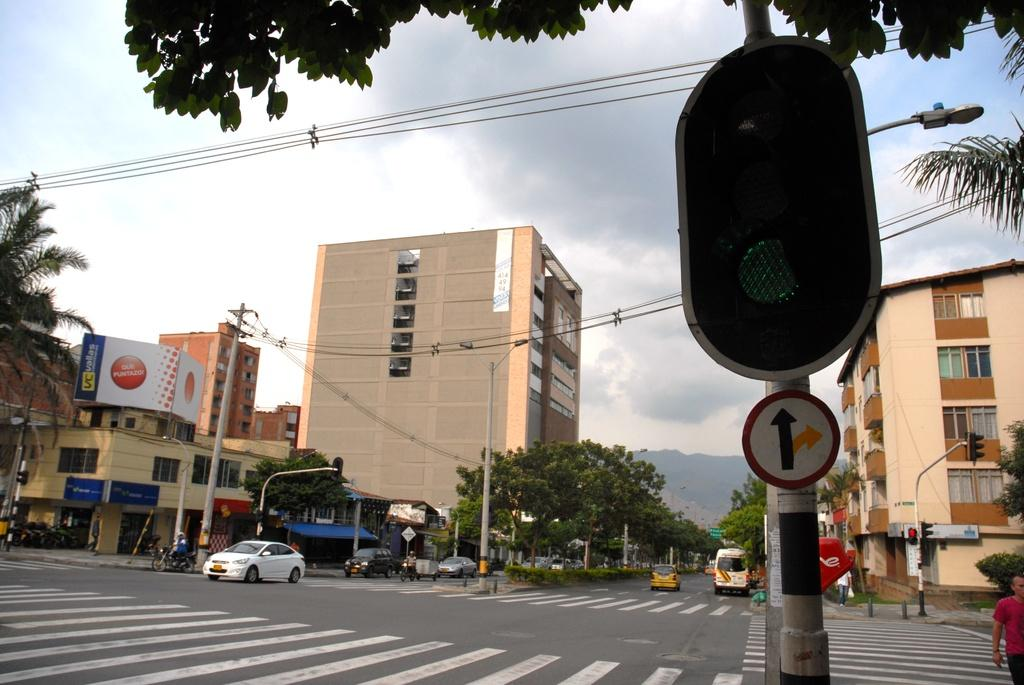What type of structures can be seen in the image? There are buildings in the image. What are the large, flat surfaces with advertisements on them? There are hoardings in the image. What are the tall, thin objects in the image? There are poles in the image. What type of vegetation is present in the image? There are trees in the image. What type of transportation can be seen in the image? There are vehicles in the image. What are the signs with information or directions on them? There are sign boards in the image. What are the lights used for controlling traffic? There are signal lights in the image. Are there any living beings in the image? Yes, there are people in the image. What type of flora is present in the image? There are plants in the image. What is the condition of the sky in the image? The sky is cloudy in the image. What general category of items can be seen in the image? There are objects in the image. Can you see any toes on the people in the image? There is no specific mention of toes in the image, so it cannot be determined if any are visible. What type of animal has a neck and fang in the image? There is no mention of any animals, let alone one with a neck and fang, in the image. 